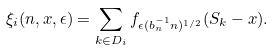<formula> <loc_0><loc_0><loc_500><loc_500>\xi _ { i } ( n , x , \epsilon ) = \sum _ { k \in D _ { i } } f _ { \epsilon ( b _ { n } ^ { - 1 } n ) ^ { 1 / 2 } } ( S _ { k } - x ) .</formula> 